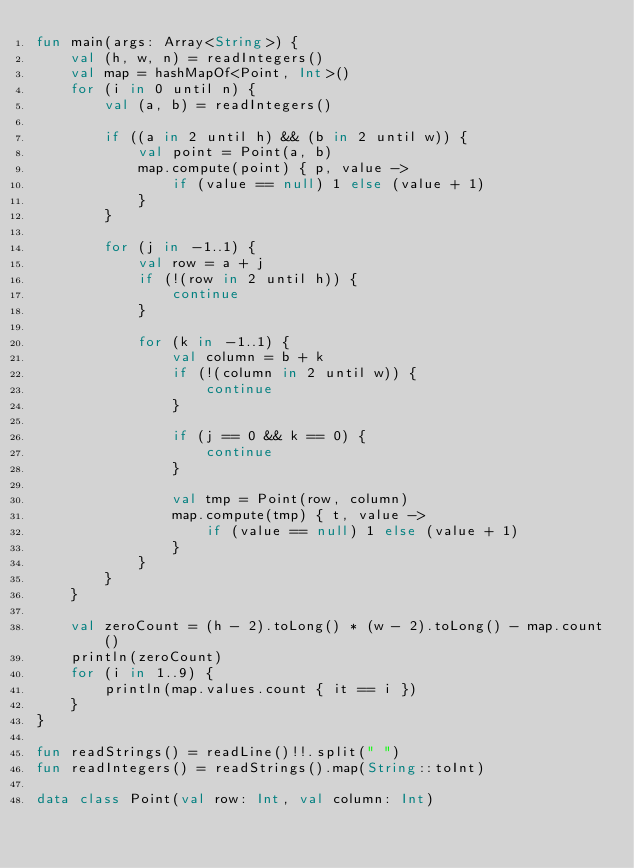<code> <loc_0><loc_0><loc_500><loc_500><_Kotlin_>fun main(args: Array<String>) {
    val (h, w, n) = readIntegers()
    val map = hashMapOf<Point, Int>()
    for (i in 0 until n) {
        val (a, b) = readIntegers()

        if ((a in 2 until h) && (b in 2 until w)) {
            val point = Point(a, b)
            map.compute(point) { p, value ->
                if (value == null) 1 else (value + 1)
            }
        }

        for (j in -1..1) {
            val row = a + j
            if (!(row in 2 until h)) {
                continue
            }

            for (k in -1..1) {
                val column = b + k
                if (!(column in 2 until w)) {
                    continue
                }

                if (j == 0 && k == 0) {
                    continue
                }

                val tmp = Point(row, column)
                map.compute(tmp) { t, value ->
                    if (value == null) 1 else (value + 1)
                }
            }
        }
    }

    val zeroCount = (h - 2).toLong() * (w - 2).toLong() - map.count()
    println(zeroCount)
    for (i in 1..9) {
        println(map.values.count { it == i })
    }
}

fun readStrings() = readLine()!!.split(" ")
fun readIntegers() = readStrings().map(String::toInt)

data class Point(val row: Int, val column: Int)
</code> 